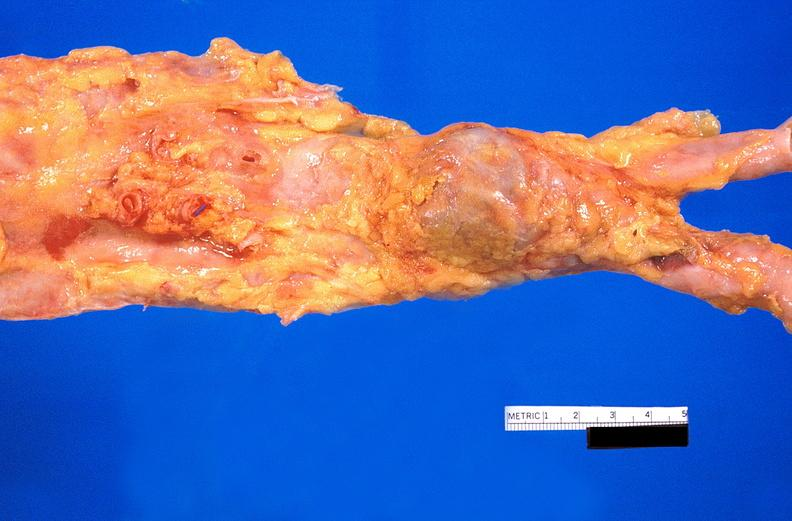what is present?
Answer the question using a single word or phrase. Cardiovascular 